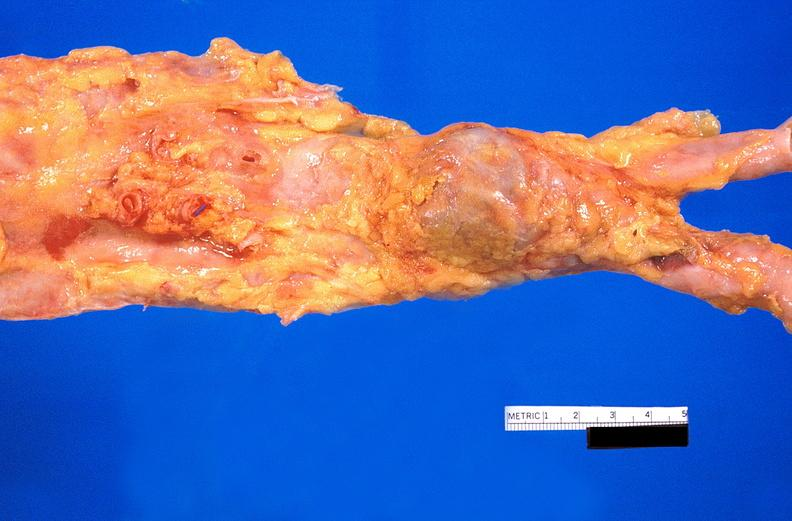what is present?
Answer the question using a single word or phrase. Cardiovascular 